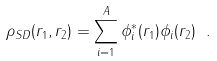Convert formula to latex. <formula><loc_0><loc_0><loc_500><loc_500>\rho _ { S D } ( { r } _ { 1 } , { r } _ { 2 } ) = \sum _ { i = 1 } ^ { A } \phi _ { i } ^ { * } ( { r } _ { 1 } ) \phi _ { i } ( { r } _ { 2 } ) \ .</formula> 